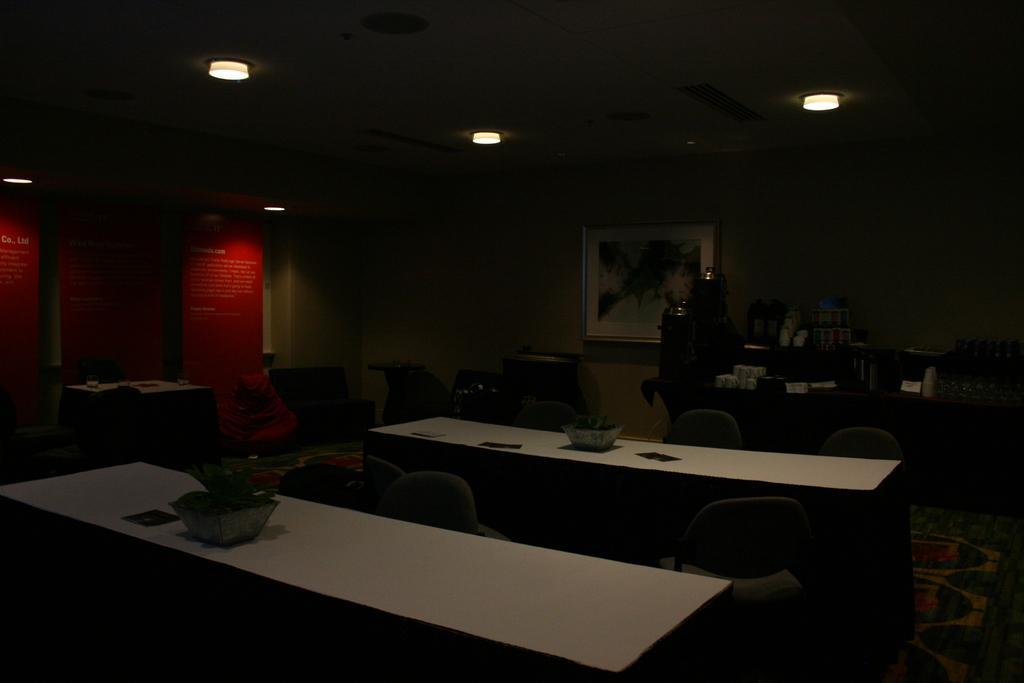Could you give a brief overview of what you see in this image? This image is taken inside a room. In the center of the image there are tables and chairs. In the background of the image there is wall. There is a photo frame on the wall. At the top of the image there is a ceiling with lights. To the left side of the image there are red color banner. At the bottom of the image there is carpet. 